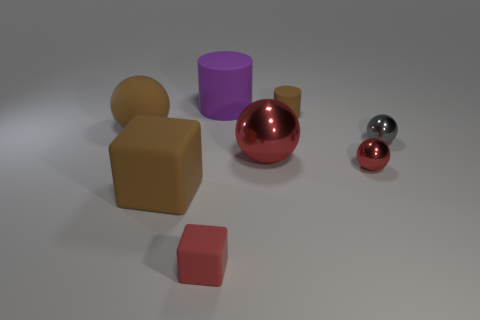Subtract all big brown balls. How many balls are left? 3 Subtract all red blocks. How many red spheres are left? 2 Subtract 4 spheres. How many spheres are left? 0 Add 2 small gray metallic spheres. How many objects exist? 10 Subtract all red blocks. How many blocks are left? 1 Subtract all cubes. How many objects are left? 6 Subtract all red blocks. Subtract all shiny balls. How many objects are left? 4 Add 4 large objects. How many large objects are left? 8 Add 2 brown cylinders. How many brown cylinders exist? 3 Subtract 0 purple balls. How many objects are left? 8 